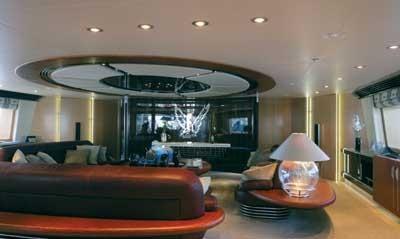How many couches are there?
Give a very brief answer. 2. How many people are riding on the elephant?
Give a very brief answer. 0. 